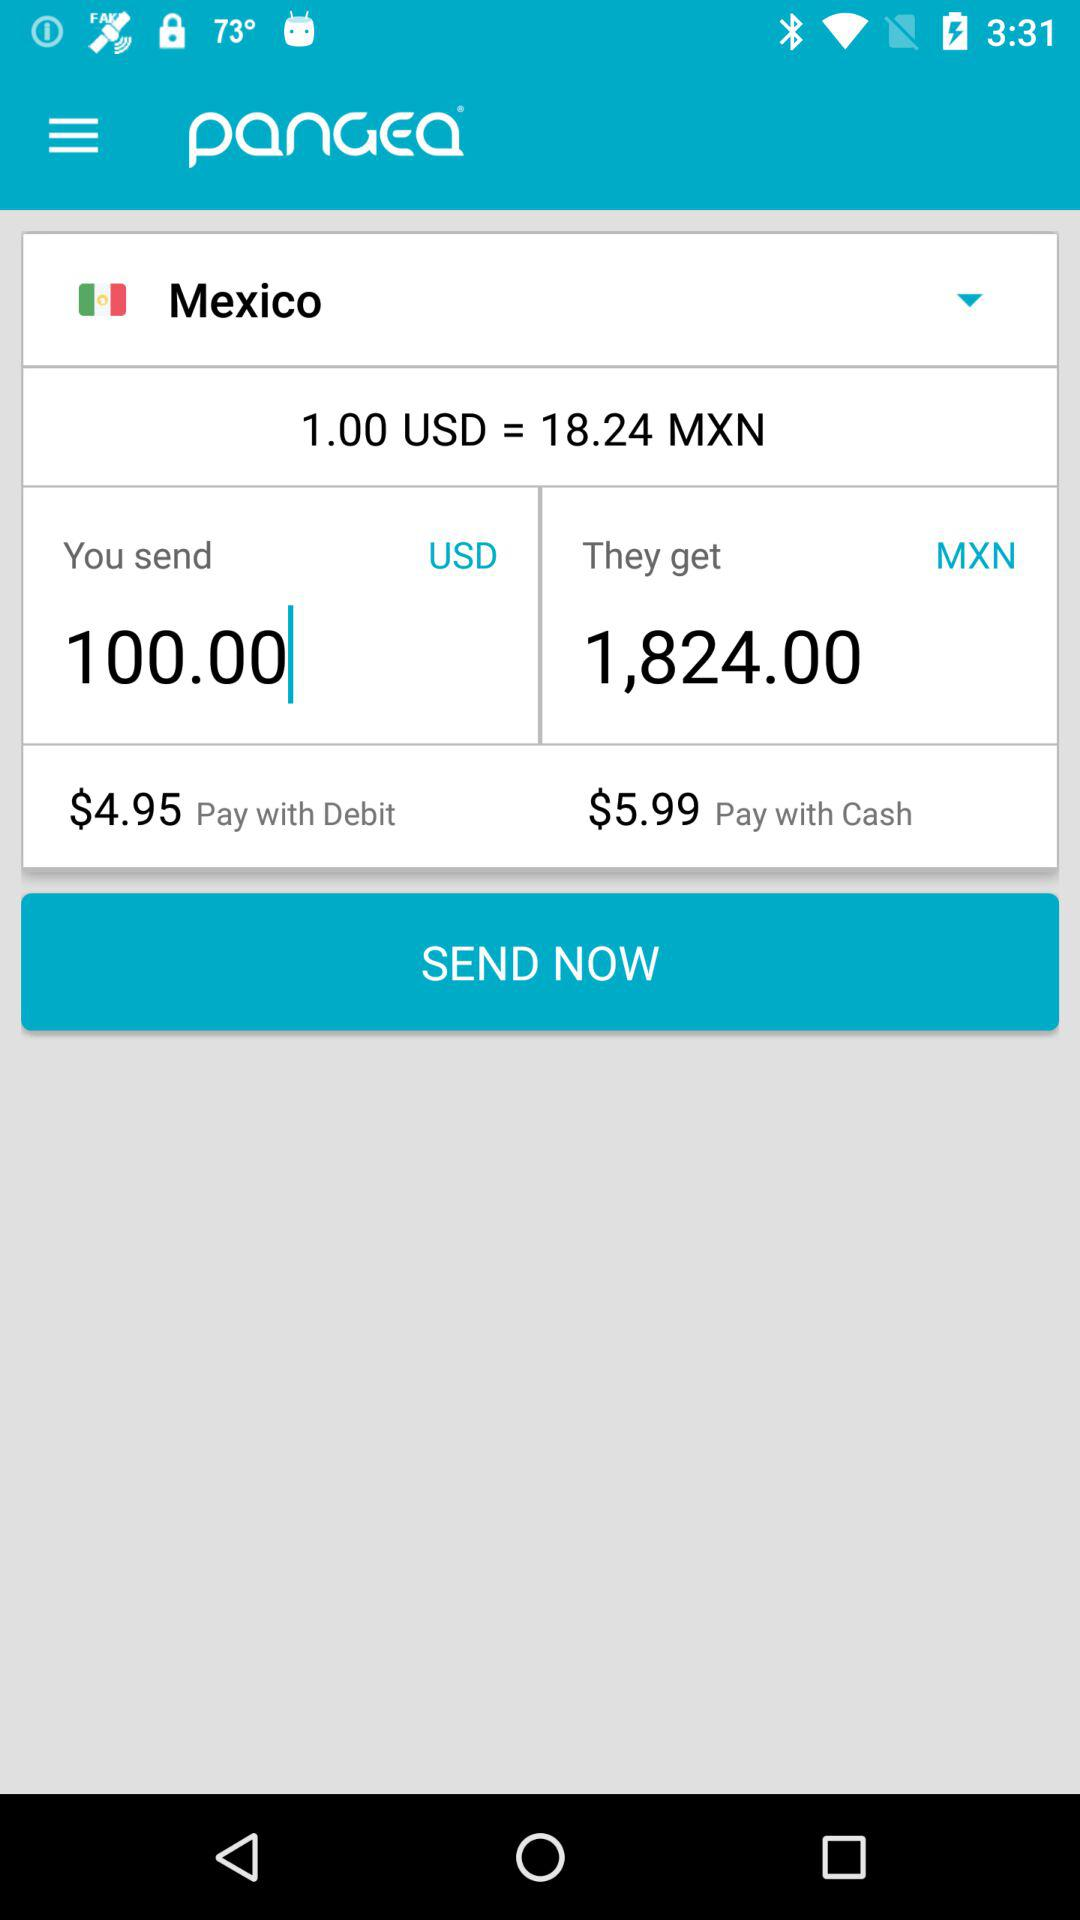How much more does it cost to pay with cash than with debit?
Answer the question using a single word or phrase. $1.04 